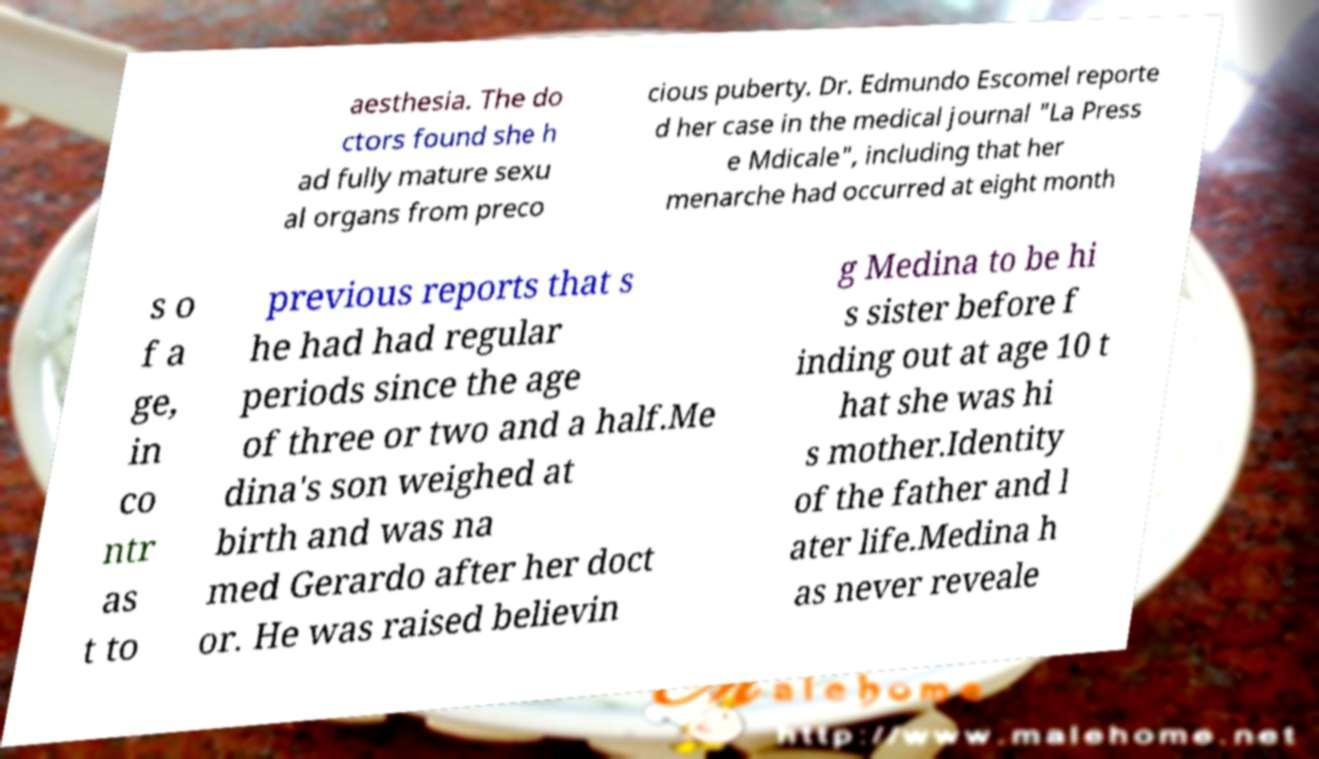I need the written content from this picture converted into text. Can you do that? aesthesia. The do ctors found she h ad fully mature sexu al organs from preco cious puberty. Dr. Edmundo Escomel reporte d her case in the medical journal "La Press e Mdicale", including that her menarche had occurred at eight month s o f a ge, in co ntr as t to previous reports that s he had had regular periods since the age of three or two and a half.Me dina's son weighed at birth and was na med Gerardo after her doct or. He was raised believin g Medina to be hi s sister before f inding out at age 10 t hat she was hi s mother.Identity of the father and l ater life.Medina h as never reveale 